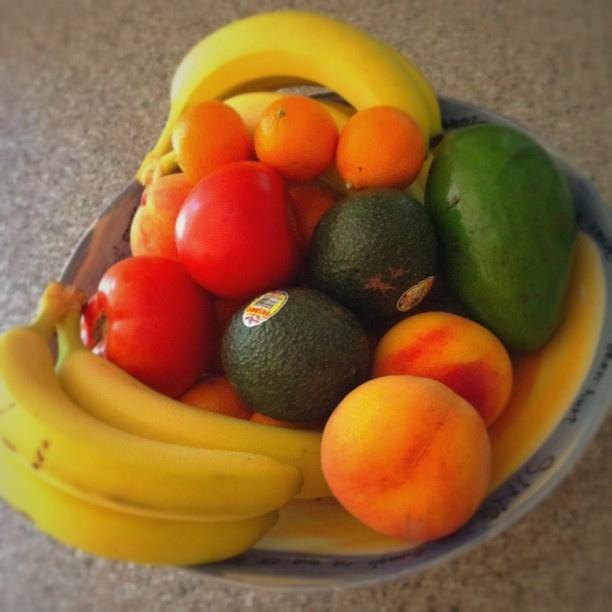Are these fruits clean?
Short answer required. Yes. Do these look ripe?
Quick response, please. Yes. Were the avocados bought in a store?
Be succinct. Yes. 